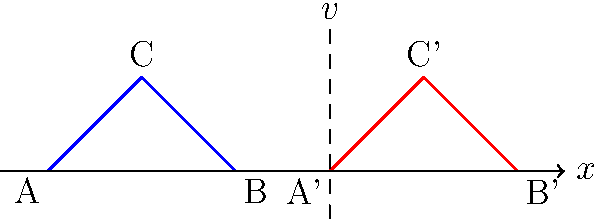Consider two congruent triangles ABC and A'B'C' in different reference frames, as shown in the figure. Triangle ABC is at rest in the laboratory frame, while triangle A'B'C' is moving to the right with velocity $v$ relative to the laboratory frame. If the velocity $v$ approaches the speed of light $c$, how will the shape of triangle A'B'C' appear to an observer in the laboratory frame, and why? To answer this question, we need to consider the effects of special relativity:

1. Length contraction: According to special relativity, objects moving at relativistic speeds appear contracted along the direction of motion to a stationary observer.

2. The length contraction factor is given by the Lorentz factor: $\gamma = \frac{1}{\sqrt{1-\frac{v^2}{c^2}}}$

3. As $v$ approaches $c$, $\gamma$ approaches infinity, meaning the contraction becomes more severe.

4. The contraction only occurs in the direction of motion (x-axis in this case). There is no change in the dimensions perpendicular to the motion (y-axis).

5. For triangle A'B'C':
   - The base A'B' will appear to contract along the x-axis.
   - The height of the triangle (perpendicular to motion) will remain unchanged.

6. As a result, to the observer in the laboratory frame, triangle A'B'C' will appear to become increasingly thin and tall as $v$ approaches $c$.

7. In the limit as $v \to c$, the triangle would theoretically appear as a vertical line segment.

8. However, it's important to note that it's physically impossible for massive objects to reach the speed of light, so this limit is purely theoretical.
Answer: As $v \to c$, triangle A'B'C' will appear increasingly thin and tall, approaching a vertical line segment due to relativistic length contraction along the direction of motion. 